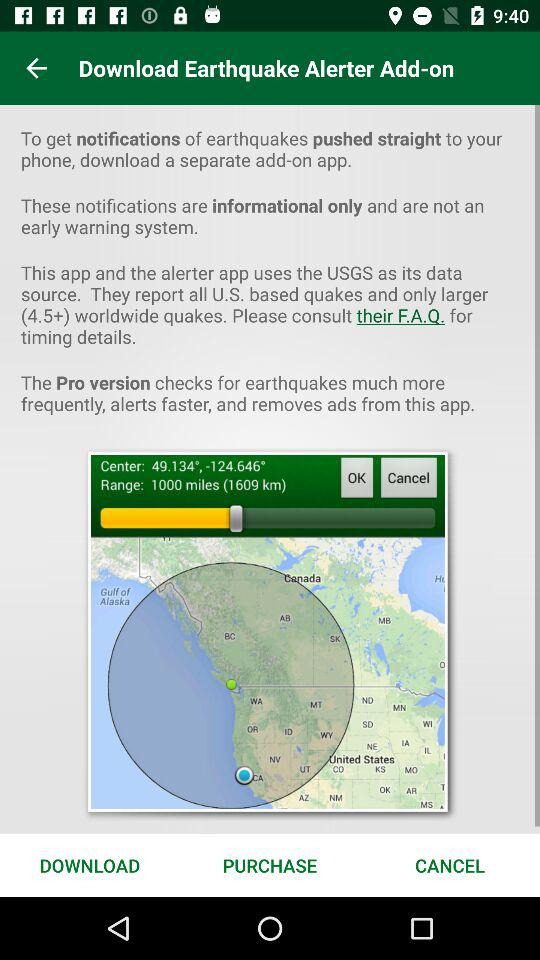What is the range of the earthquake? The range of the earthquake is 1000 miles (1609 km). 